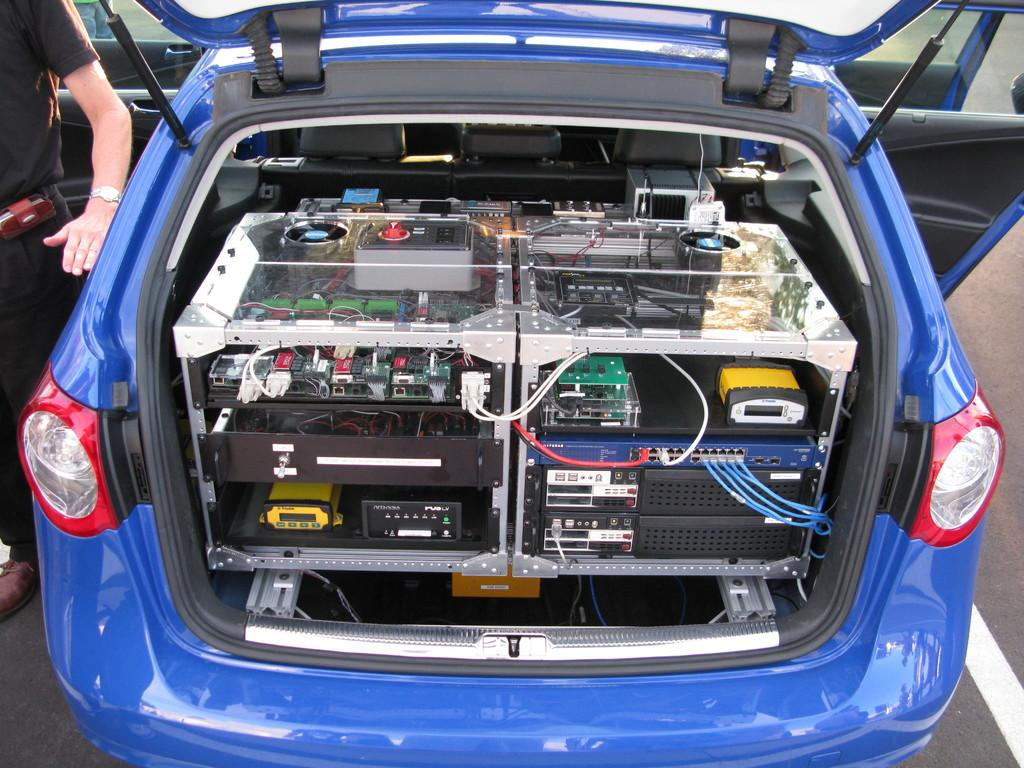What is the main subject of the image? The main subject of the image is a car. What color is the car? The car is blue in color. What can be found inside the car? There are electronic instruments in the car. Can you see the face of the car's creator in the image? There is no face or person visible in the image, as it only features a blue car with electronic instruments inside. Is there a mask visible in the image? There is no mask present in the image. 